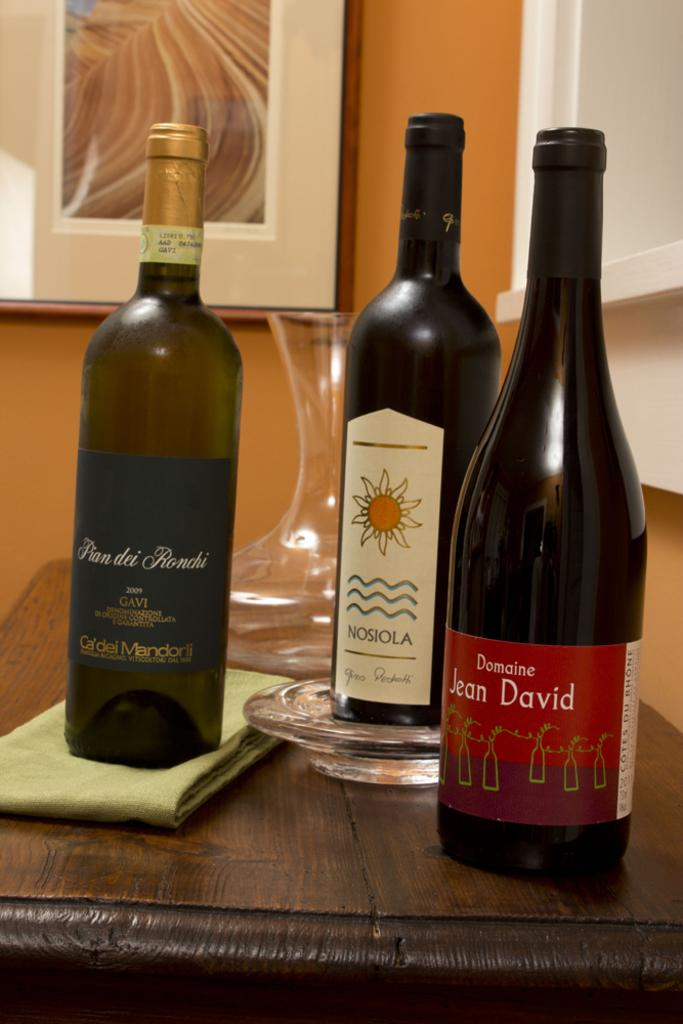<image>
Give a short and clear explanation of the subsequent image. Three bottles of wine, including once called Duncine Jean David, sit on a table in front of a clear vase. 